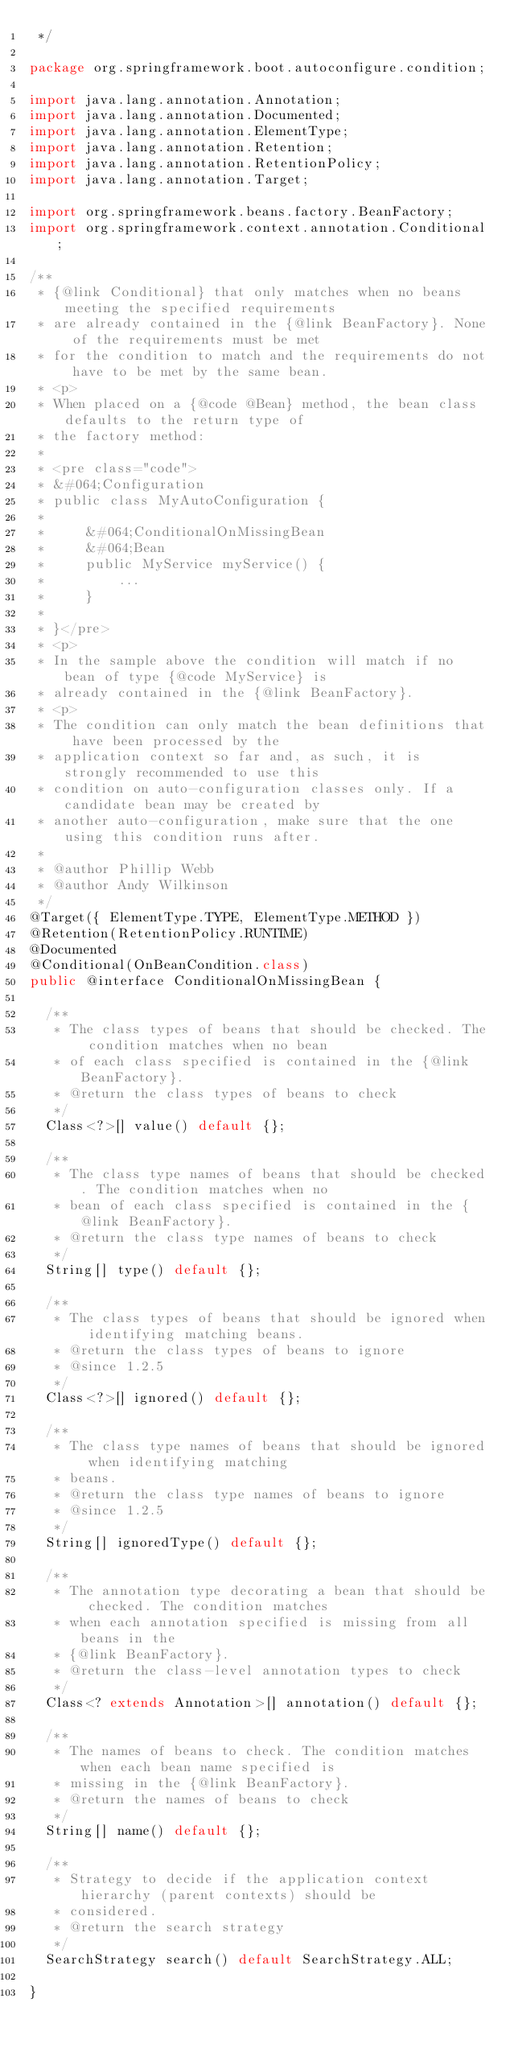Convert code to text. <code><loc_0><loc_0><loc_500><loc_500><_Java_> */

package org.springframework.boot.autoconfigure.condition;

import java.lang.annotation.Annotation;
import java.lang.annotation.Documented;
import java.lang.annotation.ElementType;
import java.lang.annotation.Retention;
import java.lang.annotation.RetentionPolicy;
import java.lang.annotation.Target;

import org.springframework.beans.factory.BeanFactory;
import org.springframework.context.annotation.Conditional;

/**
 * {@link Conditional} that only matches when no beans meeting the specified requirements
 * are already contained in the {@link BeanFactory}. None of the requirements must be met
 * for the condition to match and the requirements do not have to be met by the same bean.
 * <p>
 * When placed on a {@code @Bean} method, the bean class defaults to the return type of
 * the factory method:
 *
 * <pre class="code">
 * &#064;Configuration
 * public class MyAutoConfiguration {
 *
 *     &#064;ConditionalOnMissingBean
 *     &#064;Bean
 *     public MyService myService() {
 *         ...
 *     }
 *
 * }</pre>
 * <p>
 * In the sample above the condition will match if no bean of type {@code MyService} is
 * already contained in the {@link BeanFactory}.
 * <p>
 * The condition can only match the bean definitions that have been processed by the
 * application context so far and, as such, it is strongly recommended to use this
 * condition on auto-configuration classes only. If a candidate bean may be created by
 * another auto-configuration, make sure that the one using this condition runs after.
 *
 * @author Phillip Webb
 * @author Andy Wilkinson
 */
@Target({ ElementType.TYPE, ElementType.METHOD })
@Retention(RetentionPolicy.RUNTIME)
@Documented
@Conditional(OnBeanCondition.class)
public @interface ConditionalOnMissingBean {

	/**
	 * The class types of beans that should be checked. The condition matches when no bean
	 * of each class specified is contained in the {@link BeanFactory}.
	 * @return the class types of beans to check
	 */
	Class<?>[] value() default {};

	/**
	 * The class type names of beans that should be checked. The condition matches when no
	 * bean of each class specified is contained in the {@link BeanFactory}.
	 * @return the class type names of beans to check
	 */
	String[] type() default {};

	/**
	 * The class types of beans that should be ignored when identifying matching beans.
	 * @return the class types of beans to ignore
	 * @since 1.2.5
	 */
	Class<?>[] ignored() default {};

	/**
	 * The class type names of beans that should be ignored when identifying matching
	 * beans.
	 * @return the class type names of beans to ignore
	 * @since 1.2.5
	 */
	String[] ignoredType() default {};

	/**
	 * The annotation type decorating a bean that should be checked. The condition matches
	 * when each annotation specified is missing from all beans in the
	 * {@link BeanFactory}.
	 * @return the class-level annotation types to check
	 */
	Class<? extends Annotation>[] annotation() default {};

	/**
	 * The names of beans to check. The condition matches when each bean name specified is
	 * missing in the {@link BeanFactory}.
	 * @return the names of beans to check
	 */
	String[] name() default {};

	/**
	 * Strategy to decide if the application context hierarchy (parent contexts) should be
	 * considered.
	 * @return the search strategy
	 */
	SearchStrategy search() default SearchStrategy.ALL;

}
</code> 